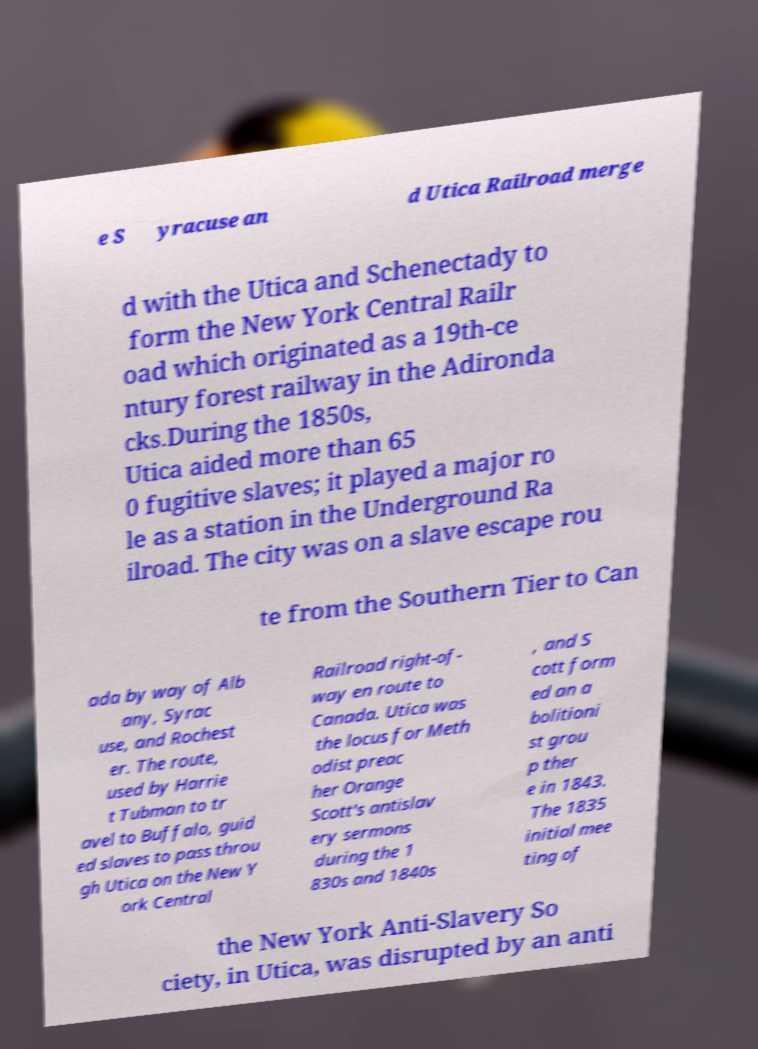Please read and relay the text visible in this image. What does it say? e S yracuse an d Utica Railroad merge d with the Utica and Schenectady to form the New York Central Railr oad which originated as a 19th-ce ntury forest railway in the Adironda cks.During the 1850s, Utica aided more than 65 0 fugitive slaves; it played a major ro le as a station in the Underground Ra ilroad. The city was on a slave escape rou te from the Southern Tier to Can ada by way of Alb any, Syrac use, and Rochest er. The route, used by Harrie t Tubman to tr avel to Buffalo, guid ed slaves to pass throu gh Utica on the New Y ork Central Railroad right-of- way en route to Canada. Utica was the locus for Meth odist preac her Orange Scott's antislav ery sermons during the 1 830s and 1840s , and S cott form ed an a bolitioni st grou p ther e in 1843. The 1835 initial mee ting of the New York Anti-Slavery So ciety, in Utica, was disrupted by an anti 